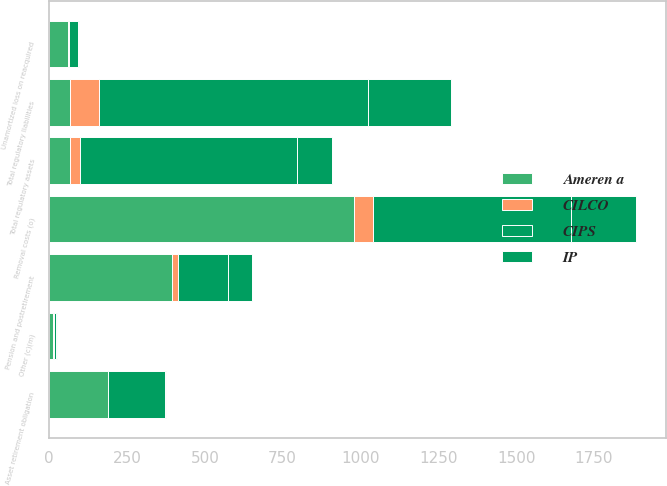<chart> <loc_0><loc_0><loc_500><loc_500><stacked_bar_chart><ecel><fcel>Pension and postretirement<fcel>Asset retirement obligation<fcel>Unamortized loss on reacquired<fcel>Other (c)(m)<fcel>Total regulatory assets<fcel>Removal costs (o)<fcel>Total regulatory liabilities<nl><fcel>Ameren a<fcel>395<fcel>188<fcel>59<fcel>13<fcel>67.5<fcel>980<fcel>67.5<nl><fcel>CIPS<fcel>161<fcel>183<fcel>28<fcel>8<fcel>697<fcel>638<fcel>865<nl><fcel>IP<fcel>75<fcel>2<fcel>4<fcel>1<fcel>113<fcel>208<fcel>265<nl><fcel>CILCO<fcel>19<fcel>1<fcel>5<fcel>2<fcel>32<fcel>60<fcel>92<nl></chart> 